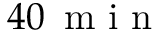Convert formula to latex. <formula><loc_0><loc_0><loc_500><loc_500>4 0 \, m i n</formula> 